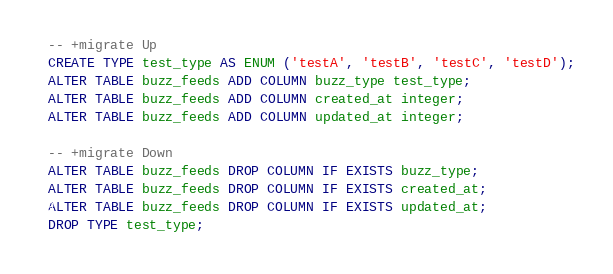<code> <loc_0><loc_0><loc_500><loc_500><_SQL_>-- +migrate Up
CREATE TYPE test_type AS ENUM ('testA', 'testB', 'testC', 'testD');
ALTER TABLE buzz_feeds ADD COLUMN buzz_type test_type;
ALTER TABLE buzz_feeds ADD COLUMN created_at integer;
ALTER TABLE buzz_feeds ADD COLUMN updated_at integer;

-- +migrate Down
ALTER TABLE buzz_feeds DROP COLUMN IF EXISTS buzz_type;
ALTER TABLE buzz_feeds DROP COLUMN IF EXISTS created_at;
ALTER TABLE buzz_feeds DROP COLUMN IF EXISTS updated_at;
DROP TYPE test_type;</code> 